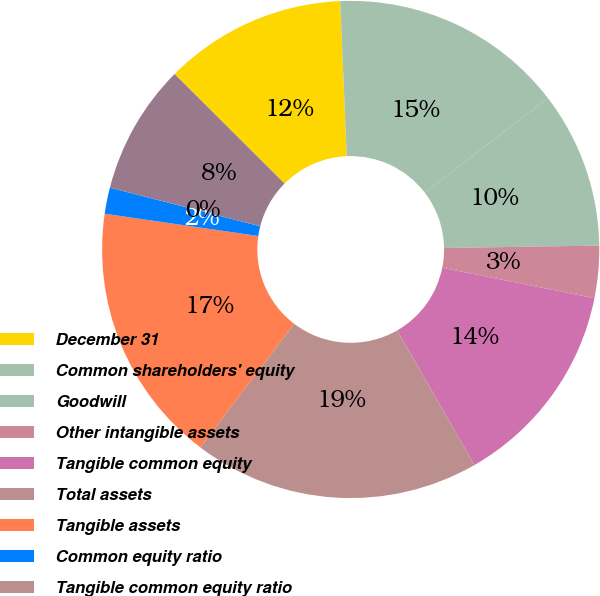<chart> <loc_0><loc_0><loc_500><loc_500><pie_chart><fcel>December 31<fcel>Common shareholders' equity<fcel>Goodwill<fcel>Other intangible assets<fcel>Tangible common equity<fcel>Total assets<fcel>Tangible assets<fcel>Common equity ratio<fcel>Tangible common equity ratio<fcel>Shares of common stock<nl><fcel>11.86%<fcel>15.25%<fcel>10.17%<fcel>3.39%<fcel>13.56%<fcel>18.64%<fcel>16.95%<fcel>1.7%<fcel>0.0%<fcel>8.47%<nl></chart> 